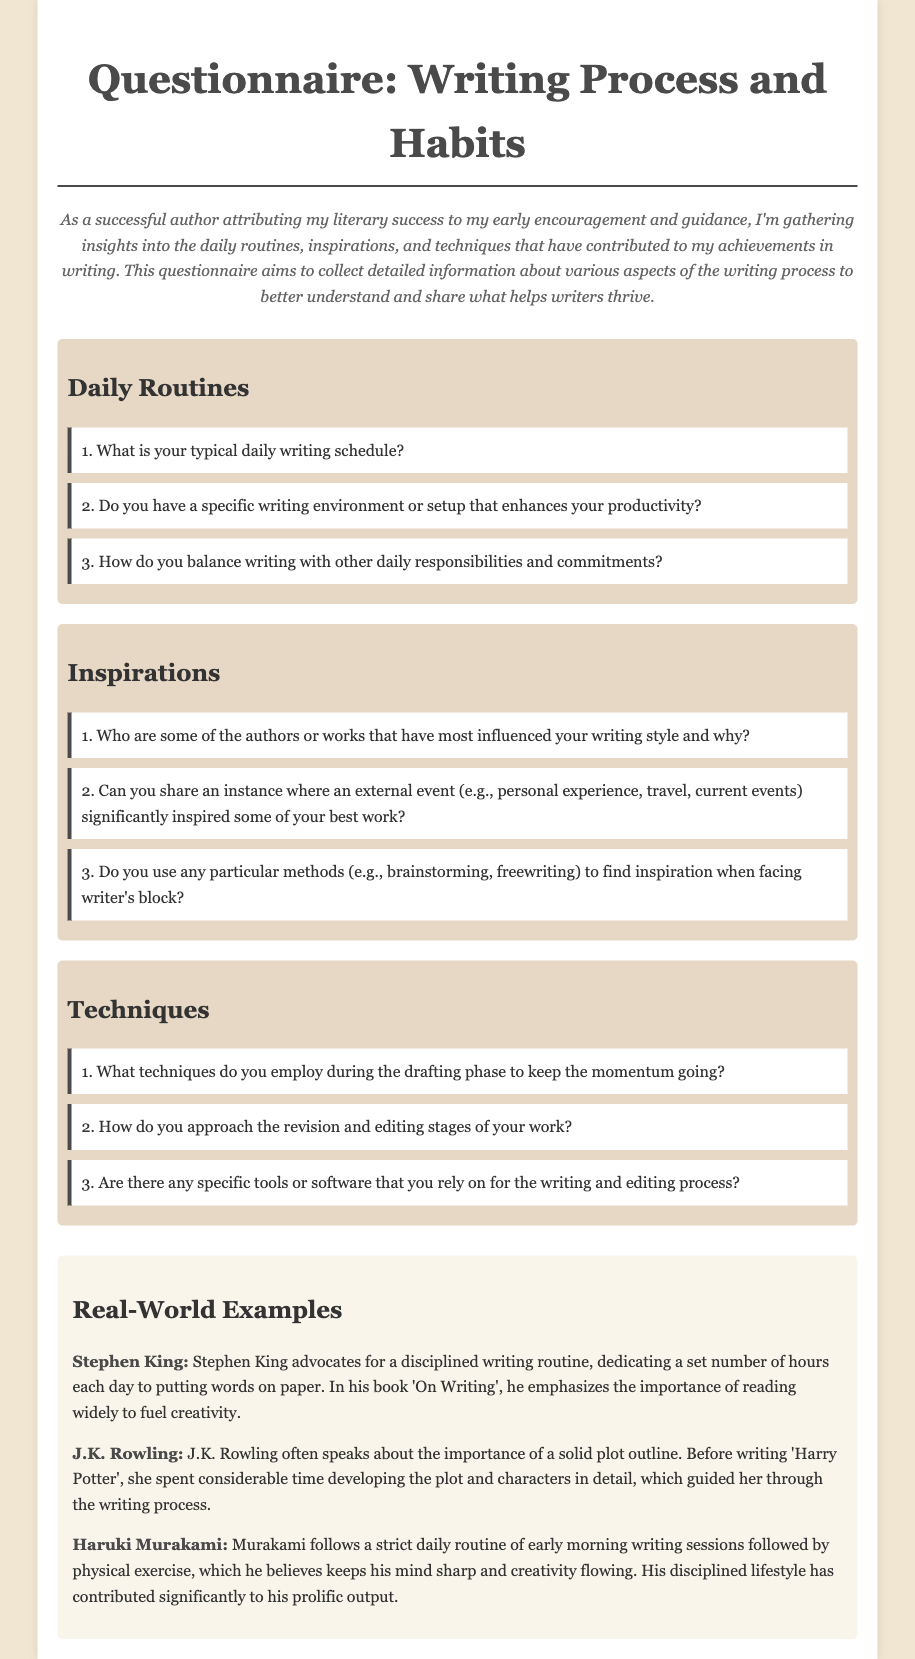What is the title of the document? The title of the document is stated in the header of the document.
Answer: Writing Process and Habits Questionnaire How many categories are included in the questionnaire? The document lists three distinct categories that contain questions.
Answer: Three Who is the author referenced in the real-world examples that advocates for a disciplined writing routine? This information is found in the examples section of the document under the author names.
Answer: Stephen King What is one method mentioned for finding inspiration during writer's block? This information is given in the Inspirations category of the document.
Answer: Freewriting Which author spent considerable time developing plot and characters before writing? This detail can be found in the examples section related to authors' techniques.
Answer: J.K. Rowling How does Haruki Murakami structure his daily routine? The document describes specific aspects of Murakami's daily writing routine.
Answer: Early morning writing sessions followed by physical exercise 